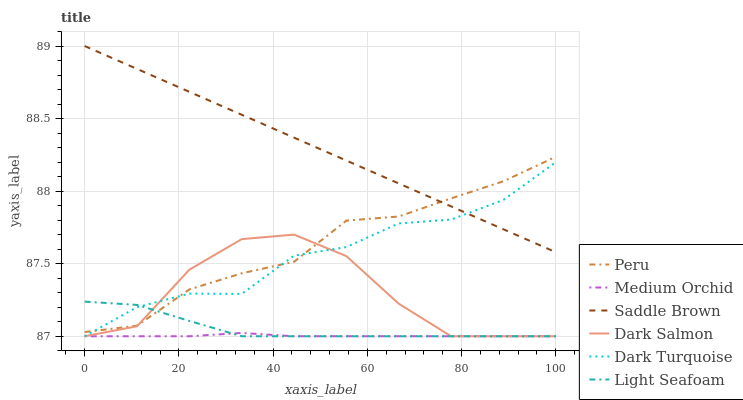Does Dark Salmon have the minimum area under the curve?
Answer yes or no. No. Does Dark Salmon have the maximum area under the curve?
Answer yes or no. No. Is Medium Orchid the smoothest?
Answer yes or no. No. Is Medium Orchid the roughest?
Answer yes or no. No. Does Peru have the lowest value?
Answer yes or no. No. Does Dark Salmon have the highest value?
Answer yes or no. No. Is Medium Orchid less than Peru?
Answer yes or no. Yes. Is Saddle Brown greater than Dark Salmon?
Answer yes or no. Yes. Does Medium Orchid intersect Peru?
Answer yes or no. No. 